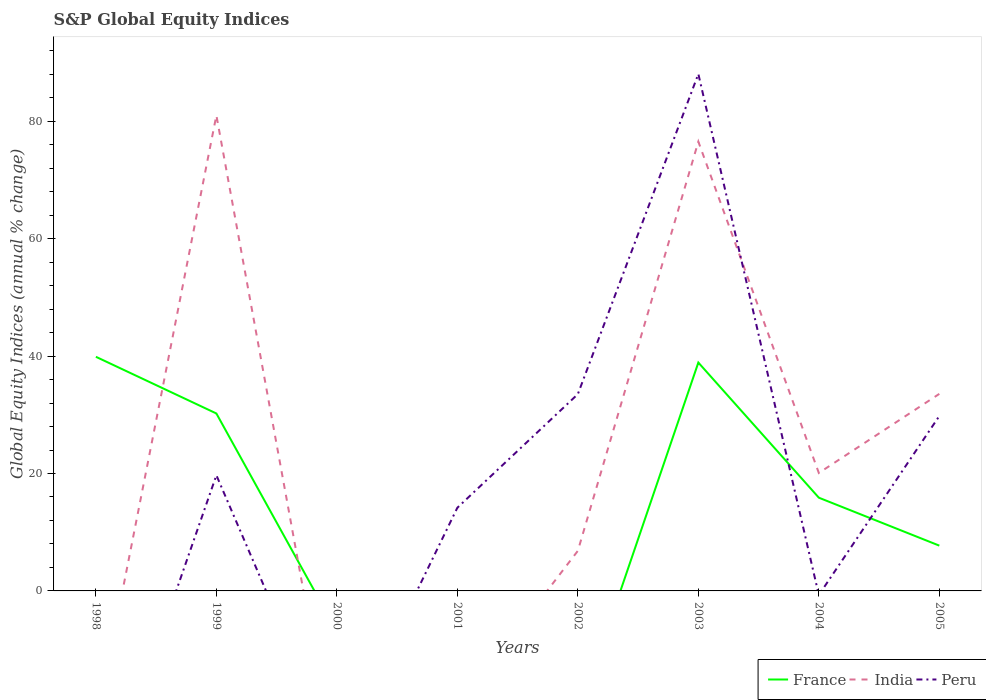How many different coloured lines are there?
Your response must be concise. 3. What is the total global equity indices in Peru in the graph?
Your answer should be compact. -68.35. What is the difference between the highest and the lowest global equity indices in France?
Provide a succinct answer. 3. Is the global equity indices in France strictly greater than the global equity indices in Peru over the years?
Your answer should be compact. No. How many years are there in the graph?
Provide a succinct answer. 8. What is the difference between two consecutive major ticks on the Y-axis?
Offer a very short reply. 20. Where does the legend appear in the graph?
Your response must be concise. Bottom right. How are the legend labels stacked?
Provide a succinct answer. Horizontal. What is the title of the graph?
Your answer should be very brief. S&P Global Equity Indices. Does "St. Kitts and Nevis" appear as one of the legend labels in the graph?
Ensure brevity in your answer.  No. What is the label or title of the X-axis?
Provide a short and direct response. Years. What is the label or title of the Y-axis?
Keep it short and to the point. Global Equity Indices (annual % change). What is the Global Equity Indices (annual % change) of France in 1998?
Keep it short and to the point. 39.88. What is the Global Equity Indices (annual % change) in Peru in 1998?
Your answer should be compact. 0. What is the Global Equity Indices (annual % change) in France in 1999?
Offer a terse response. 30.22. What is the Global Equity Indices (annual % change) in India in 1999?
Provide a succinct answer. 81. What is the Global Equity Indices (annual % change) of Peru in 1999?
Your response must be concise. 19.7. What is the Global Equity Indices (annual % change) in France in 2000?
Your answer should be compact. 0. What is the Global Equity Indices (annual % change) of India in 2000?
Your answer should be compact. 0. What is the Global Equity Indices (annual % change) of France in 2001?
Your answer should be compact. 0. What is the Global Equity Indices (annual % change) in India in 2001?
Provide a succinct answer. 0. What is the Global Equity Indices (annual % change) of Peru in 2001?
Offer a terse response. 14.17. What is the Global Equity Indices (annual % change) in France in 2002?
Provide a short and direct response. 0. What is the Global Equity Indices (annual % change) in India in 2002?
Offer a very short reply. 6.83. What is the Global Equity Indices (annual % change) in Peru in 2002?
Give a very brief answer. 33.52. What is the Global Equity Indices (annual % change) of France in 2003?
Offer a terse response. 38.9. What is the Global Equity Indices (annual % change) of India in 2003?
Your answer should be compact. 76.52. What is the Global Equity Indices (annual % change) in Peru in 2003?
Keep it short and to the point. 88.05. What is the Global Equity Indices (annual % change) of France in 2004?
Make the answer very short. 15.88. What is the Global Equity Indices (annual % change) in India in 2004?
Give a very brief answer. 20.09. What is the Global Equity Indices (annual % change) in Peru in 2004?
Keep it short and to the point. 0. What is the Global Equity Indices (annual % change) of France in 2005?
Offer a terse response. 7.71. What is the Global Equity Indices (annual % change) of India in 2005?
Give a very brief answer. 33.56. What is the Global Equity Indices (annual % change) in Peru in 2005?
Ensure brevity in your answer.  29.8. Across all years, what is the maximum Global Equity Indices (annual % change) in France?
Keep it short and to the point. 39.88. Across all years, what is the maximum Global Equity Indices (annual % change) in India?
Offer a terse response. 81. Across all years, what is the maximum Global Equity Indices (annual % change) in Peru?
Your response must be concise. 88.05. Across all years, what is the minimum Global Equity Indices (annual % change) in France?
Provide a succinct answer. 0. Across all years, what is the minimum Global Equity Indices (annual % change) of Peru?
Offer a very short reply. 0. What is the total Global Equity Indices (annual % change) in France in the graph?
Your answer should be compact. 132.59. What is the total Global Equity Indices (annual % change) in India in the graph?
Keep it short and to the point. 218. What is the total Global Equity Indices (annual % change) of Peru in the graph?
Your response must be concise. 185.24. What is the difference between the Global Equity Indices (annual % change) in France in 1998 and that in 1999?
Give a very brief answer. 9.66. What is the difference between the Global Equity Indices (annual % change) in France in 1998 and that in 2003?
Your answer should be compact. 0.98. What is the difference between the Global Equity Indices (annual % change) in France in 1998 and that in 2004?
Offer a terse response. 24. What is the difference between the Global Equity Indices (annual % change) of France in 1998 and that in 2005?
Give a very brief answer. 32.17. What is the difference between the Global Equity Indices (annual % change) of Peru in 1999 and that in 2001?
Offer a very short reply. 5.53. What is the difference between the Global Equity Indices (annual % change) in India in 1999 and that in 2002?
Give a very brief answer. 74.17. What is the difference between the Global Equity Indices (annual % change) of Peru in 1999 and that in 2002?
Provide a succinct answer. -13.82. What is the difference between the Global Equity Indices (annual % change) of France in 1999 and that in 2003?
Provide a short and direct response. -8.67. What is the difference between the Global Equity Indices (annual % change) in India in 1999 and that in 2003?
Give a very brief answer. 4.48. What is the difference between the Global Equity Indices (annual % change) in Peru in 1999 and that in 2003?
Ensure brevity in your answer.  -68.35. What is the difference between the Global Equity Indices (annual % change) of France in 1999 and that in 2004?
Ensure brevity in your answer.  14.35. What is the difference between the Global Equity Indices (annual % change) of India in 1999 and that in 2004?
Offer a terse response. 60.91. What is the difference between the Global Equity Indices (annual % change) in France in 1999 and that in 2005?
Keep it short and to the point. 22.51. What is the difference between the Global Equity Indices (annual % change) in India in 1999 and that in 2005?
Keep it short and to the point. 47.44. What is the difference between the Global Equity Indices (annual % change) in Peru in 1999 and that in 2005?
Ensure brevity in your answer.  -10.1. What is the difference between the Global Equity Indices (annual % change) of Peru in 2001 and that in 2002?
Provide a short and direct response. -19.35. What is the difference between the Global Equity Indices (annual % change) in Peru in 2001 and that in 2003?
Offer a very short reply. -73.88. What is the difference between the Global Equity Indices (annual % change) in Peru in 2001 and that in 2005?
Provide a succinct answer. -15.63. What is the difference between the Global Equity Indices (annual % change) of India in 2002 and that in 2003?
Provide a short and direct response. -69.69. What is the difference between the Global Equity Indices (annual % change) in Peru in 2002 and that in 2003?
Keep it short and to the point. -54.53. What is the difference between the Global Equity Indices (annual % change) of India in 2002 and that in 2004?
Make the answer very short. -13.26. What is the difference between the Global Equity Indices (annual % change) in India in 2002 and that in 2005?
Offer a terse response. -26.73. What is the difference between the Global Equity Indices (annual % change) of Peru in 2002 and that in 2005?
Your answer should be very brief. 3.72. What is the difference between the Global Equity Indices (annual % change) of France in 2003 and that in 2004?
Give a very brief answer. 23.02. What is the difference between the Global Equity Indices (annual % change) in India in 2003 and that in 2004?
Give a very brief answer. 56.43. What is the difference between the Global Equity Indices (annual % change) in France in 2003 and that in 2005?
Your answer should be very brief. 31.18. What is the difference between the Global Equity Indices (annual % change) of India in 2003 and that in 2005?
Keep it short and to the point. 42.96. What is the difference between the Global Equity Indices (annual % change) of Peru in 2003 and that in 2005?
Provide a succinct answer. 58.25. What is the difference between the Global Equity Indices (annual % change) of France in 2004 and that in 2005?
Offer a terse response. 8.17. What is the difference between the Global Equity Indices (annual % change) of India in 2004 and that in 2005?
Make the answer very short. -13.47. What is the difference between the Global Equity Indices (annual % change) of France in 1998 and the Global Equity Indices (annual % change) of India in 1999?
Offer a very short reply. -41.12. What is the difference between the Global Equity Indices (annual % change) in France in 1998 and the Global Equity Indices (annual % change) in Peru in 1999?
Keep it short and to the point. 20.18. What is the difference between the Global Equity Indices (annual % change) in France in 1998 and the Global Equity Indices (annual % change) in Peru in 2001?
Your response must be concise. 25.71. What is the difference between the Global Equity Indices (annual % change) in France in 1998 and the Global Equity Indices (annual % change) in India in 2002?
Provide a short and direct response. 33.05. What is the difference between the Global Equity Indices (annual % change) of France in 1998 and the Global Equity Indices (annual % change) of Peru in 2002?
Your answer should be very brief. 6.36. What is the difference between the Global Equity Indices (annual % change) in France in 1998 and the Global Equity Indices (annual % change) in India in 2003?
Your answer should be very brief. -36.64. What is the difference between the Global Equity Indices (annual % change) of France in 1998 and the Global Equity Indices (annual % change) of Peru in 2003?
Provide a succinct answer. -48.17. What is the difference between the Global Equity Indices (annual % change) of France in 1998 and the Global Equity Indices (annual % change) of India in 2004?
Your answer should be very brief. 19.79. What is the difference between the Global Equity Indices (annual % change) of France in 1998 and the Global Equity Indices (annual % change) of India in 2005?
Provide a succinct answer. 6.32. What is the difference between the Global Equity Indices (annual % change) of France in 1998 and the Global Equity Indices (annual % change) of Peru in 2005?
Ensure brevity in your answer.  10.08. What is the difference between the Global Equity Indices (annual % change) of France in 1999 and the Global Equity Indices (annual % change) of Peru in 2001?
Offer a terse response. 16.05. What is the difference between the Global Equity Indices (annual % change) of India in 1999 and the Global Equity Indices (annual % change) of Peru in 2001?
Your answer should be compact. 66.83. What is the difference between the Global Equity Indices (annual % change) of France in 1999 and the Global Equity Indices (annual % change) of India in 2002?
Make the answer very short. 23.39. What is the difference between the Global Equity Indices (annual % change) of France in 1999 and the Global Equity Indices (annual % change) of Peru in 2002?
Give a very brief answer. -3.3. What is the difference between the Global Equity Indices (annual % change) of India in 1999 and the Global Equity Indices (annual % change) of Peru in 2002?
Offer a very short reply. 47.48. What is the difference between the Global Equity Indices (annual % change) in France in 1999 and the Global Equity Indices (annual % change) in India in 2003?
Make the answer very short. -46.3. What is the difference between the Global Equity Indices (annual % change) in France in 1999 and the Global Equity Indices (annual % change) in Peru in 2003?
Your answer should be very brief. -57.83. What is the difference between the Global Equity Indices (annual % change) in India in 1999 and the Global Equity Indices (annual % change) in Peru in 2003?
Provide a short and direct response. -7.05. What is the difference between the Global Equity Indices (annual % change) of France in 1999 and the Global Equity Indices (annual % change) of India in 2004?
Offer a very short reply. 10.13. What is the difference between the Global Equity Indices (annual % change) of France in 1999 and the Global Equity Indices (annual % change) of India in 2005?
Your response must be concise. -3.34. What is the difference between the Global Equity Indices (annual % change) of France in 1999 and the Global Equity Indices (annual % change) of Peru in 2005?
Your answer should be very brief. 0.43. What is the difference between the Global Equity Indices (annual % change) of India in 1999 and the Global Equity Indices (annual % change) of Peru in 2005?
Your response must be concise. 51.2. What is the difference between the Global Equity Indices (annual % change) in India in 2002 and the Global Equity Indices (annual % change) in Peru in 2003?
Your answer should be very brief. -81.22. What is the difference between the Global Equity Indices (annual % change) in India in 2002 and the Global Equity Indices (annual % change) in Peru in 2005?
Offer a terse response. -22.97. What is the difference between the Global Equity Indices (annual % change) of France in 2003 and the Global Equity Indices (annual % change) of India in 2004?
Provide a short and direct response. 18.81. What is the difference between the Global Equity Indices (annual % change) of France in 2003 and the Global Equity Indices (annual % change) of India in 2005?
Your response must be concise. 5.33. What is the difference between the Global Equity Indices (annual % change) of France in 2003 and the Global Equity Indices (annual % change) of Peru in 2005?
Give a very brief answer. 9.1. What is the difference between the Global Equity Indices (annual % change) in India in 2003 and the Global Equity Indices (annual % change) in Peru in 2005?
Ensure brevity in your answer.  46.72. What is the difference between the Global Equity Indices (annual % change) in France in 2004 and the Global Equity Indices (annual % change) in India in 2005?
Your answer should be very brief. -17.68. What is the difference between the Global Equity Indices (annual % change) in France in 2004 and the Global Equity Indices (annual % change) in Peru in 2005?
Offer a very short reply. -13.92. What is the difference between the Global Equity Indices (annual % change) of India in 2004 and the Global Equity Indices (annual % change) of Peru in 2005?
Your answer should be very brief. -9.71. What is the average Global Equity Indices (annual % change) of France per year?
Your answer should be compact. 16.57. What is the average Global Equity Indices (annual % change) in India per year?
Keep it short and to the point. 27.25. What is the average Global Equity Indices (annual % change) in Peru per year?
Your answer should be compact. 23.15. In the year 1999, what is the difference between the Global Equity Indices (annual % change) of France and Global Equity Indices (annual % change) of India?
Give a very brief answer. -50.78. In the year 1999, what is the difference between the Global Equity Indices (annual % change) in France and Global Equity Indices (annual % change) in Peru?
Provide a succinct answer. 10.52. In the year 1999, what is the difference between the Global Equity Indices (annual % change) of India and Global Equity Indices (annual % change) of Peru?
Provide a short and direct response. 61.3. In the year 2002, what is the difference between the Global Equity Indices (annual % change) in India and Global Equity Indices (annual % change) in Peru?
Your answer should be compact. -26.69. In the year 2003, what is the difference between the Global Equity Indices (annual % change) of France and Global Equity Indices (annual % change) of India?
Provide a succinct answer. -37.62. In the year 2003, what is the difference between the Global Equity Indices (annual % change) of France and Global Equity Indices (annual % change) of Peru?
Keep it short and to the point. -49.15. In the year 2003, what is the difference between the Global Equity Indices (annual % change) of India and Global Equity Indices (annual % change) of Peru?
Offer a very short reply. -11.53. In the year 2004, what is the difference between the Global Equity Indices (annual % change) in France and Global Equity Indices (annual % change) in India?
Make the answer very short. -4.21. In the year 2005, what is the difference between the Global Equity Indices (annual % change) in France and Global Equity Indices (annual % change) in India?
Your response must be concise. -25.85. In the year 2005, what is the difference between the Global Equity Indices (annual % change) in France and Global Equity Indices (annual % change) in Peru?
Ensure brevity in your answer.  -22.08. In the year 2005, what is the difference between the Global Equity Indices (annual % change) of India and Global Equity Indices (annual % change) of Peru?
Make the answer very short. 3.77. What is the ratio of the Global Equity Indices (annual % change) of France in 1998 to that in 1999?
Keep it short and to the point. 1.32. What is the ratio of the Global Equity Indices (annual % change) of France in 1998 to that in 2003?
Offer a very short reply. 1.03. What is the ratio of the Global Equity Indices (annual % change) of France in 1998 to that in 2004?
Ensure brevity in your answer.  2.51. What is the ratio of the Global Equity Indices (annual % change) in France in 1998 to that in 2005?
Make the answer very short. 5.17. What is the ratio of the Global Equity Indices (annual % change) in Peru in 1999 to that in 2001?
Ensure brevity in your answer.  1.39. What is the ratio of the Global Equity Indices (annual % change) of India in 1999 to that in 2002?
Give a very brief answer. 11.86. What is the ratio of the Global Equity Indices (annual % change) in Peru in 1999 to that in 2002?
Give a very brief answer. 0.59. What is the ratio of the Global Equity Indices (annual % change) of France in 1999 to that in 2003?
Provide a short and direct response. 0.78. What is the ratio of the Global Equity Indices (annual % change) of India in 1999 to that in 2003?
Your answer should be very brief. 1.06. What is the ratio of the Global Equity Indices (annual % change) in Peru in 1999 to that in 2003?
Provide a short and direct response. 0.22. What is the ratio of the Global Equity Indices (annual % change) in France in 1999 to that in 2004?
Keep it short and to the point. 1.9. What is the ratio of the Global Equity Indices (annual % change) of India in 1999 to that in 2004?
Offer a terse response. 4.03. What is the ratio of the Global Equity Indices (annual % change) of France in 1999 to that in 2005?
Your answer should be very brief. 3.92. What is the ratio of the Global Equity Indices (annual % change) in India in 1999 to that in 2005?
Make the answer very short. 2.41. What is the ratio of the Global Equity Indices (annual % change) in Peru in 1999 to that in 2005?
Keep it short and to the point. 0.66. What is the ratio of the Global Equity Indices (annual % change) in Peru in 2001 to that in 2002?
Your answer should be compact. 0.42. What is the ratio of the Global Equity Indices (annual % change) in Peru in 2001 to that in 2003?
Your response must be concise. 0.16. What is the ratio of the Global Equity Indices (annual % change) in Peru in 2001 to that in 2005?
Make the answer very short. 0.48. What is the ratio of the Global Equity Indices (annual % change) in India in 2002 to that in 2003?
Offer a terse response. 0.09. What is the ratio of the Global Equity Indices (annual % change) of Peru in 2002 to that in 2003?
Keep it short and to the point. 0.38. What is the ratio of the Global Equity Indices (annual % change) in India in 2002 to that in 2004?
Your response must be concise. 0.34. What is the ratio of the Global Equity Indices (annual % change) in India in 2002 to that in 2005?
Provide a succinct answer. 0.2. What is the ratio of the Global Equity Indices (annual % change) in France in 2003 to that in 2004?
Provide a succinct answer. 2.45. What is the ratio of the Global Equity Indices (annual % change) in India in 2003 to that in 2004?
Your response must be concise. 3.81. What is the ratio of the Global Equity Indices (annual % change) of France in 2003 to that in 2005?
Ensure brevity in your answer.  5.04. What is the ratio of the Global Equity Indices (annual % change) in India in 2003 to that in 2005?
Make the answer very short. 2.28. What is the ratio of the Global Equity Indices (annual % change) of Peru in 2003 to that in 2005?
Ensure brevity in your answer.  2.96. What is the ratio of the Global Equity Indices (annual % change) in France in 2004 to that in 2005?
Keep it short and to the point. 2.06. What is the ratio of the Global Equity Indices (annual % change) in India in 2004 to that in 2005?
Keep it short and to the point. 0.6. What is the difference between the highest and the second highest Global Equity Indices (annual % change) of France?
Your answer should be very brief. 0.98. What is the difference between the highest and the second highest Global Equity Indices (annual % change) of India?
Keep it short and to the point. 4.48. What is the difference between the highest and the second highest Global Equity Indices (annual % change) of Peru?
Provide a short and direct response. 54.53. What is the difference between the highest and the lowest Global Equity Indices (annual % change) in France?
Provide a succinct answer. 39.88. What is the difference between the highest and the lowest Global Equity Indices (annual % change) in Peru?
Your answer should be very brief. 88.05. 